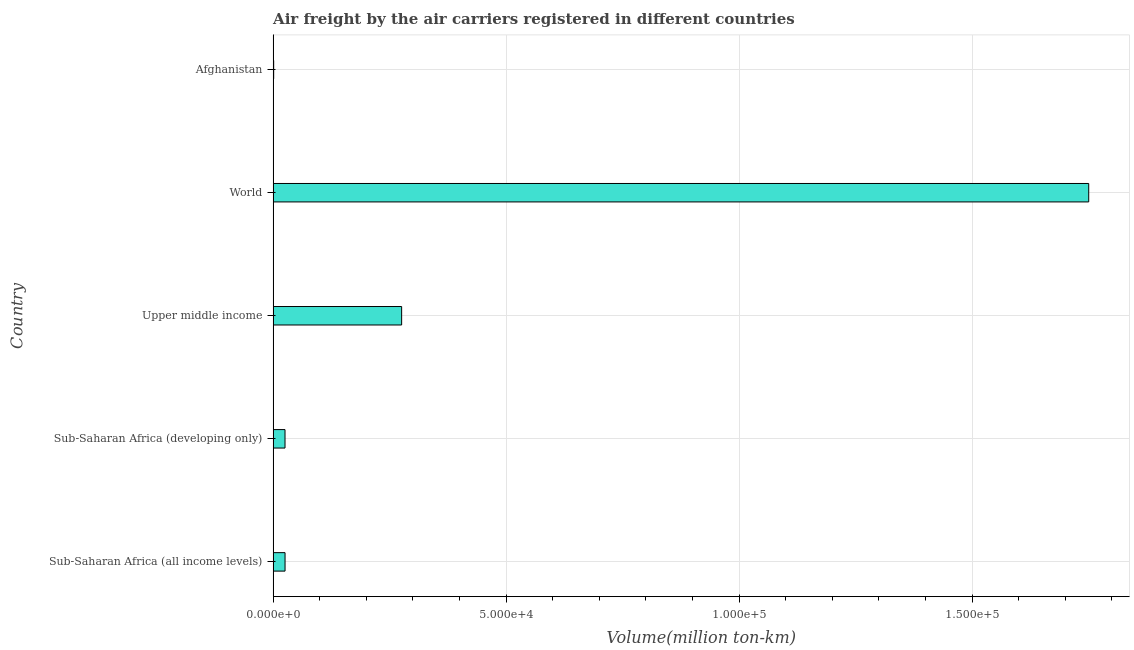Does the graph contain any zero values?
Make the answer very short. No. Does the graph contain grids?
Your answer should be very brief. Yes. What is the title of the graph?
Provide a short and direct response. Air freight by the air carriers registered in different countries. What is the label or title of the X-axis?
Make the answer very short. Volume(million ton-km). What is the label or title of the Y-axis?
Offer a terse response. Country. What is the air freight in Sub-Saharan Africa (all income levels)?
Keep it short and to the point. 2559.17. Across all countries, what is the maximum air freight?
Give a very brief answer. 1.75e+05. Across all countries, what is the minimum air freight?
Provide a short and direct response. 116.66. In which country was the air freight minimum?
Offer a very short reply. Afghanistan. What is the sum of the air freight?
Provide a succinct answer. 2.08e+05. What is the difference between the air freight in Afghanistan and Upper middle income?
Ensure brevity in your answer.  -2.75e+04. What is the average air freight per country?
Your answer should be compact. 4.16e+04. What is the median air freight?
Make the answer very short. 2559.17. In how many countries, is the air freight greater than 80000 million ton-km?
Your answer should be very brief. 1. What is the ratio of the air freight in Afghanistan to that in Upper middle income?
Provide a succinct answer. 0. What is the difference between the highest and the second highest air freight?
Your answer should be very brief. 1.47e+05. Is the sum of the air freight in Sub-Saharan Africa (developing only) and Upper middle income greater than the maximum air freight across all countries?
Ensure brevity in your answer.  No. What is the difference between the highest and the lowest air freight?
Your answer should be very brief. 1.75e+05. How many bars are there?
Make the answer very short. 5. Are all the bars in the graph horizontal?
Your response must be concise. Yes. Are the values on the major ticks of X-axis written in scientific E-notation?
Your answer should be compact. Yes. What is the Volume(million ton-km) in Sub-Saharan Africa (all income levels)?
Offer a terse response. 2559.17. What is the Volume(million ton-km) of Sub-Saharan Africa (developing only)?
Give a very brief answer. 2551.93. What is the Volume(million ton-km) of Upper middle income?
Offer a terse response. 2.76e+04. What is the Volume(million ton-km) in World?
Ensure brevity in your answer.  1.75e+05. What is the Volume(million ton-km) in Afghanistan?
Your response must be concise. 116.66. What is the difference between the Volume(million ton-km) in Sub-Saharan Africa (all income levels) and Sub-Saharan Africa (developing only)?
Ensure brevity in your answer.  7.25. What is the difference between the Volume(million ton-km) in Sub-Saharan Africa (all income levels) and Upper middle income?
Make the answer very short. -2.50e+04. What is the difference between the Volume(million ton-km) in Sub-Saharan Africa (all income levels) and World?
Provide a short and direct response. -1.72e+05. What is the difference between the Volume(million ton-km) in Sub-Saharan Africa (all income levels) and Afghanistan?
Keep it short and to the point. 2442.51. What is the difference between the Volume(million ton-km) in Sub-Saharan Africa (developing only) and Upper middle income?
Your answer should be compact. -2.50e+04. What is the difference between the Volume(million ton-km) in Sub-Saharan Africa (developing only) and World?
Offer a terse response. -1.72e+05. What is the difference between the Volume(million ton-km) in Sub-Saharan Africa (developing only) and Afghanistan?
Give a very brief answer. 2435.27. What is the difference between the Volume(million ton-km) in Upper middle income and World?
Offer a terse response. -1.47e+05. What is the difference between the Volume(million ton-km) in Upper middle income and Afghanistan?
Offer a terse response. 2.75e+04. What is the difference between the Volume(million ton-km) in World and Afghanistan?
Ensure brevity in your answer.  1.75e+05. What is the ratio of the Volume(million ton-km) in Sub-Saharan Africa (all income levels) to that in Sub-Saharan Africa (developing only)?
Your answer should be very brief. 1. What is the ratio of the Volume(million ton-km) in Sub-Saharan Africa (all income levels) to that in Upper middle income?
Offer a terse response. 0.09. What is the ratio of the Volume(million ton-km) in Sub-Saharan Africa (all income levels) to that in World?
Make the answer very short. 0.01. What is the ratio of the Volume(million ton-km) in Sub-Saharan Africa (all income levels) to that in Afghanistan?
Give a very brief answer. 21.94. What is the ratio of the Volume(million ton-km) in Sub-Saharan Africa (developing only) to that in Upper middle income?
Ensure brevity in your answer.  0.09. What is the ratio of the Volume(million ton-km) in Sub-Saharan Africa (developing only) to that in World?
Your response must be concise. 0.01. What is the ratio of the Volume(million ton-km) in Sub-Saharan Africa (developing only) to that in Afghanistan?
Keep it short and to the point. 21.88. What is the ratio of the Volume(million ton-km) in Upper middle income to that in World?
Offer a very short reply. 0.16. What is the ratio of the Volume(million ton-km) in Upper middle income to that in Afghanistan?
Your answer should be compact. 236.45. What is the ratio of the Volume(million ton-km) in World to that in Afghanistan?
Your response must be concise. 1500.44. 